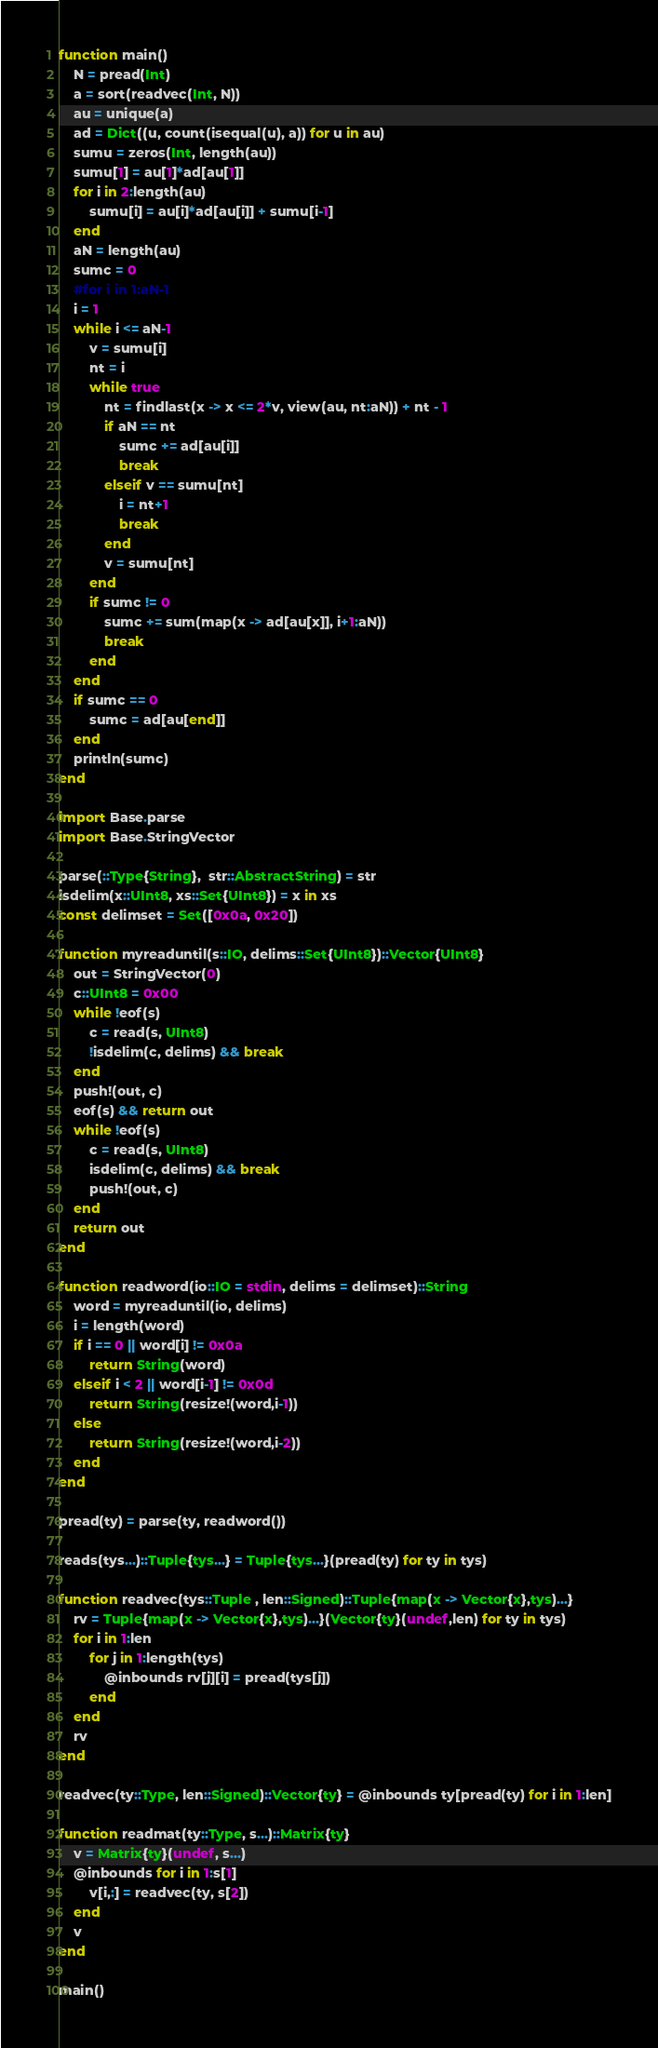Convert code to text. <code><loc_0><loc_0><loc_500><loc_500><_Julia_>function main()
    N = pread(Int)
    a = sort(readvec(Int, N))
    au = unique(a)
    ad = Dict((u, count(isequal(u), a)) for u in au)
    sumu = zeros(Int, length(au))
    sumu[1] = au[1]*ad[au[1]]
    for i in 2:length(au)
        sumu[i] = au[i]*ad[au[i]] + sumu[i-1]
    end
    aN = length(au)
    sumc = 0
    #for i in 1:aN-1
    i = 1
    while i <= aN-1
        v = sumu[i]
        nt = i
        while true
            nt = findlast(x -> x <= 2*v, view(au, nt:aN)) + nt - 1
            if aN == nt
                sumc += ad[au[i]]
                break
            elseif v == sumu[nt]
                i = nt+1
                break
            end
            v = sumu[nt]
        end
        if sumc != 0
            sumc += sum(map(x -> ad[au[x]], i+1:aN))
            break
        end
    end
    if sumc == 0
        sumc = ad[au[end]]
    end
    println(sumc)
end

import Base.parse
import Base.StringVector

parse(::Type{String},  str::AbstractString) = str
isdelim(x::UInt8, xs::Set{UInt8}) = x in xs
const delimset = Set([0x0a, 0x20])

function myreaduntil(s::IO, delims::Set{UInt8})::Vector{UInt8}
    out = StringVector(0)
    c::UInt8 = 0x00
    while !eof(s)
        c = read(s, UInt8)
        !isdelim(c, delims) && break
    end
    push!(out, c)
    eof(s) && return out
    while !eof(s)
        c = read(s, UInt8)
        isdelim(c, delims) && break
        push!(out, c)
    end
    return out
end

function readword(io::IO = stdin, delims = delimset)::String
    word = myreaduntil(io, delims)
    i = length(word)
    if i == 0 || word[i] != 0x0a
        return String(word)
    elseif i < 2 || word[i-1] != 0x0d
        return String(resize!(word,i-1))
    else
        return String(resize!(word,i-2))
    end
end

pread(ty) = parse(ty, readword())

reads(tys...)::Tuple{tys...} = Tuple{tys...}(pread(ty) for ty in tys)

function readvec(tys::Tuple , len::Signed)::Tuple{map(x -> Vector{x},tys)...}
    rv = Tuple{map(x -> Vector{x},tys)...}(Vector{ty}(undef,len) for ty in tys)
    for i in 1:len
        for j in 1:length(tys)
            @inbounds rv[j][i] = pread(tys[j])
        end
    end
    rv
end

readvec(ty::Type, len::Signed)::Vector{ty} = @inbounds ty[pread(ty) for i in 1:len]

function readmat(ty::Type, s...)::Matrix{ty}
    v = Matrix{ty}(undef, s...)
    @inbounds for i in 1:s[1]
        v[i,:] = readvec(ty, s[2])
    end
    v
end

main()
</code> 